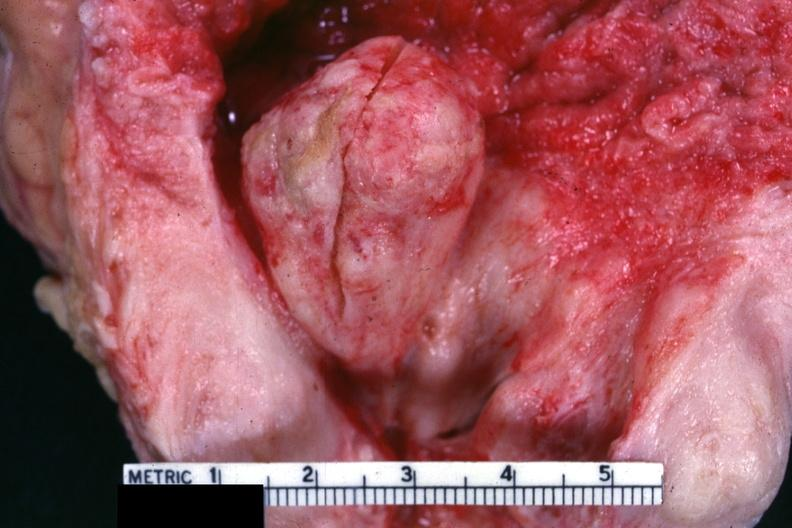what is present?
Answer the question using a single word or phrase. Prostate 